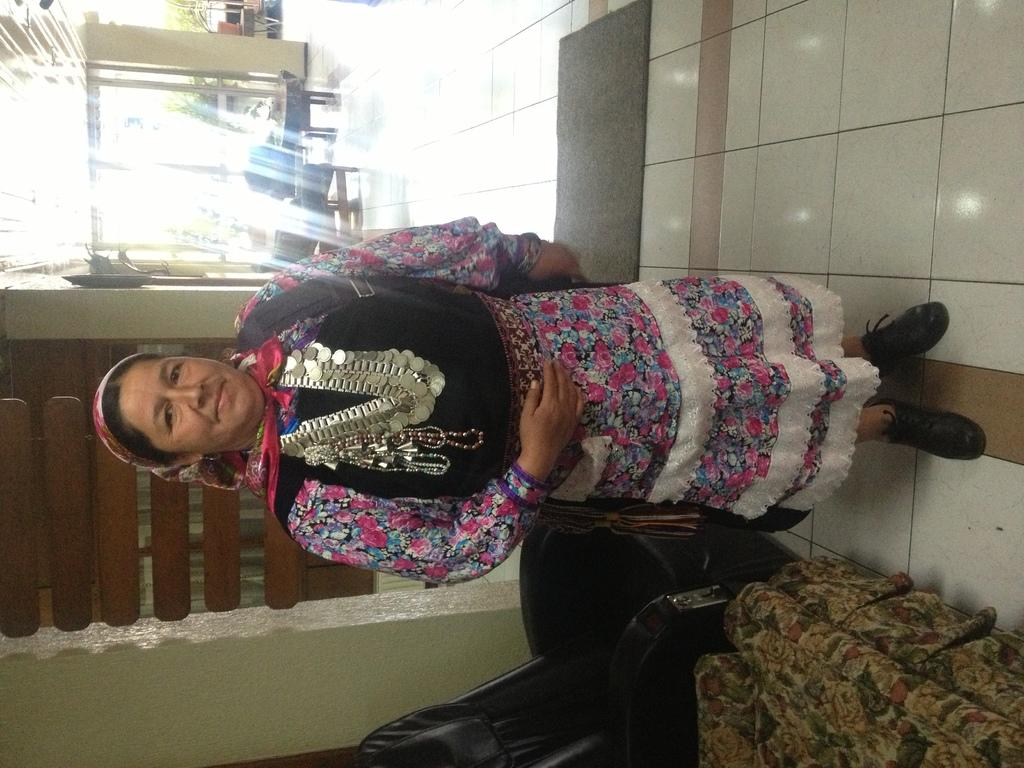What is the main subject in the image? There is a woman standing in the image. What type of furniture is visible at the bottom of the image? There are chairs at the bottom of the image. Can you describe the setting in the background of the image? There is a table and additional chairs in the background of the image. What type of hole can be seen near the seashore in the image? There is no hole or seashore present in the image; it features a woman standing with chairs and a table in the background. 